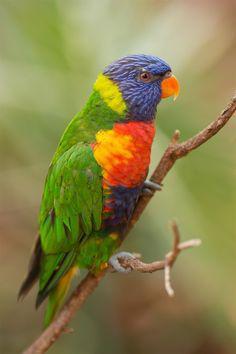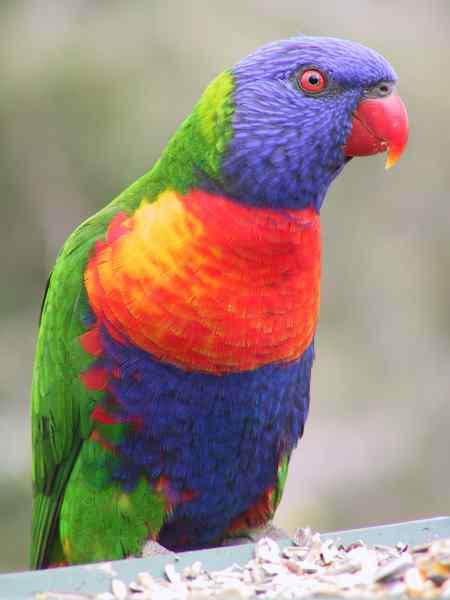The first image is the image on the left, the second image is the image on the right. Assess this claim about the two images: "Some birds are touching each other in at least one photo.". Correct or not? Answer yes or no. No. The first image is the image on the left, the second image is the image on the right. Examine the images to the left and right. Is the description "The left image contains only one multi-colored parrot." accurate? Answer yes or no. Yes. 